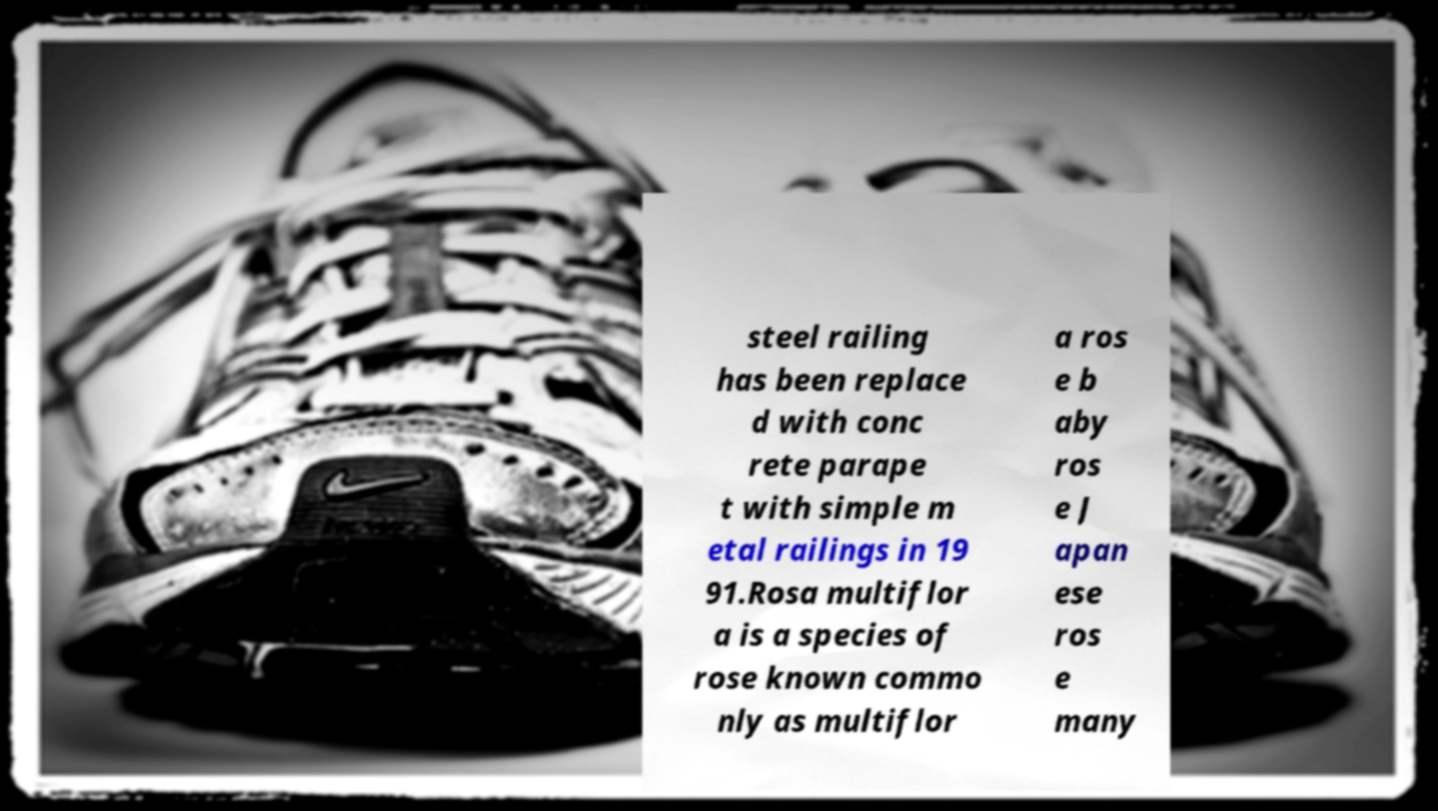Could you assist in decoding the text presented in this image and type it out clearly? steel railing has been replace d with conc rete parape t with simple m etal railings in 19 91.Rosa multiflor a is a species of rose known commo nly as multiflor a ros e b aby ros e J apan ese ros e many 